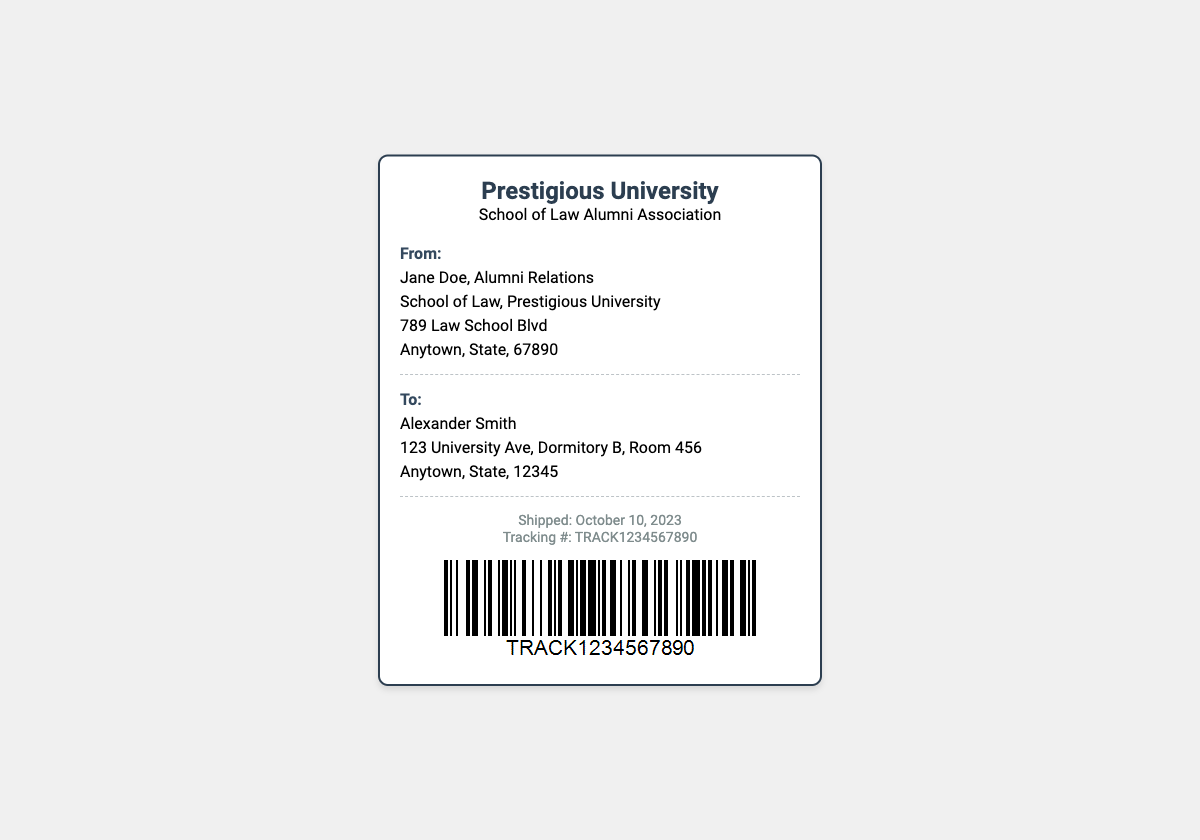What is the name of the sender? The sender is identified in the 'From' section of the label, indicating their name and title.
Answer: Jane Doe What is the address of the sender? The address of the sender is included in the 'From' section, listing the complete details.
Answer: 789 Law School Blvd, Anytown, State, 67890 Who is the recipient? The 'To' section of the document specifies the name of the recipient.
Answer: Alexander Smith What is the complete address of the recipient? The 'To' section includes the full address of the recipient, which is outlined in detail.
Answer: 123 University Ave, Dormitory B, Room 456, Anytown, State, 12345 When was the item shipped? The document states the shipping date clearly in the tracking section.
Answer: October 10, 2023 What is the tracking number? The tracking number is provided in the tracking section of the label.
Answer: TRACK1234567890 What organization is sending the package? The logo at the top of the document indicates the organization responsible for sending the package.
Answer: School of Law Alumni Association What type of item is being sent? The title of the document and the context indicate the nature of the item being sent.
Answer: Personalized Legal Journal What visual element is included for tracking? The presence of a specific image type in the document helps with tracking.
Answer: Barcode 